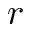Convert formula to latex. <formula><loc_0><loc_0><loc_500><loc_500>r</formula> 